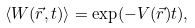<formula> <loc_0><loc_0><loc_500><loc_500>\langle W ( \vec { r } , t ) \rangle = \exp ( - V ( \vec { r } ) t ) ,</formula> 